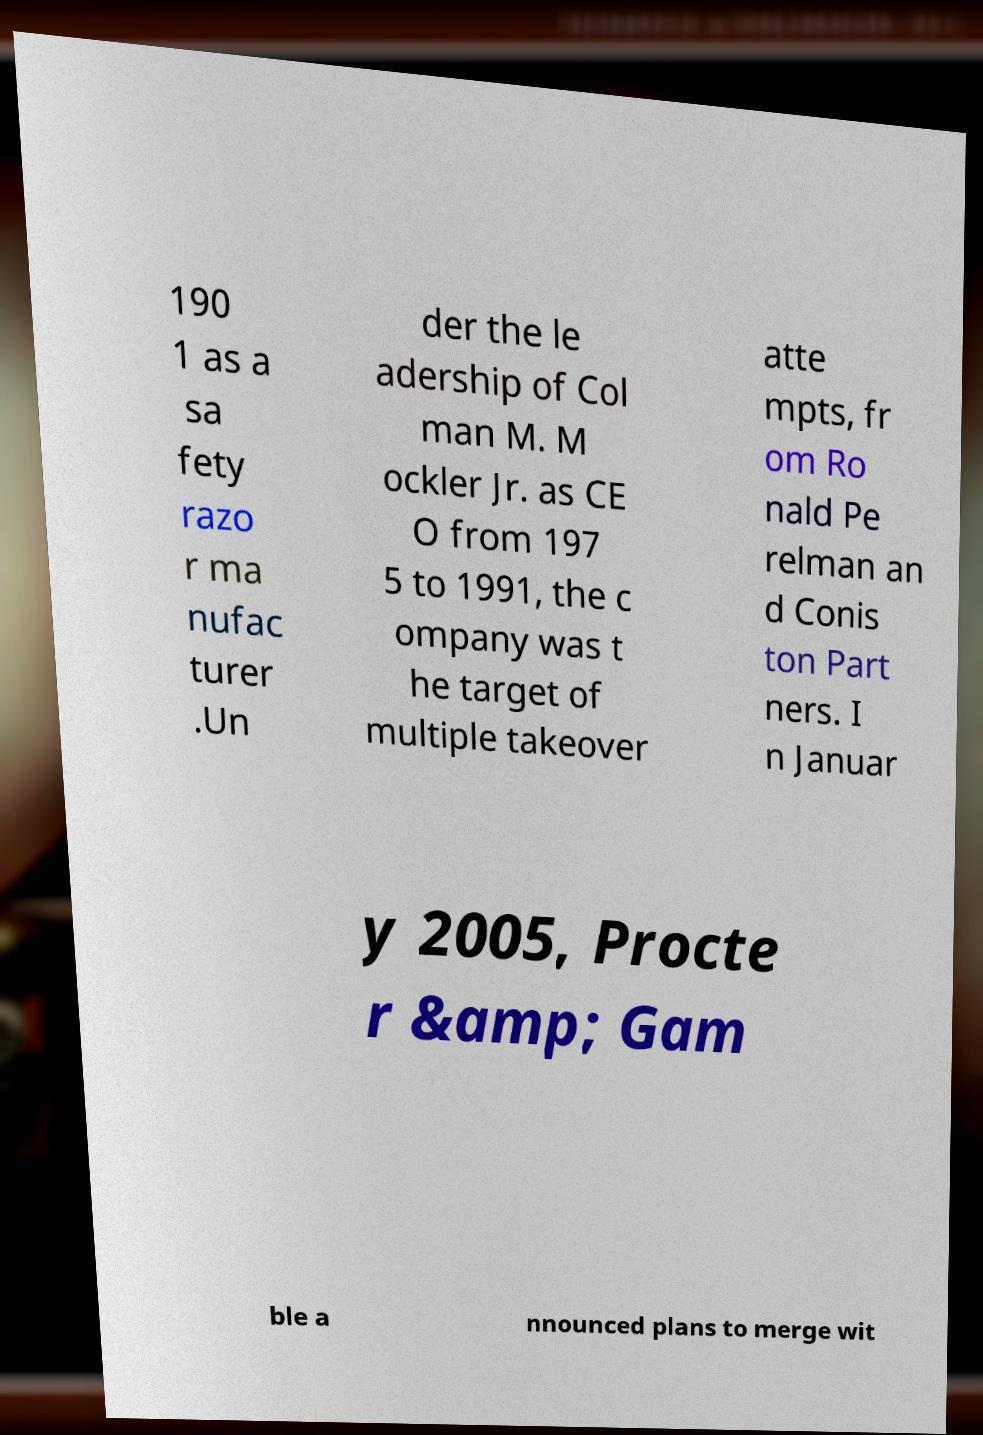Can you read and provide the text displayed in the image?This photo seems to have some interesting text. Can you extract and type it out for me? 190 1 as a sa fety razo r ma nufac turer .Un der the le adership of Col man M. M ockler Jr. as CE O from 197 5 to 1991, the c ompany was t he target of multiple takeover atte mpts, fr om Ro nald Pe relman an d Conis ton Part ners. I n Januar y 2005, Procte r &amp; Gam ble a nnounced plans to merge wit 